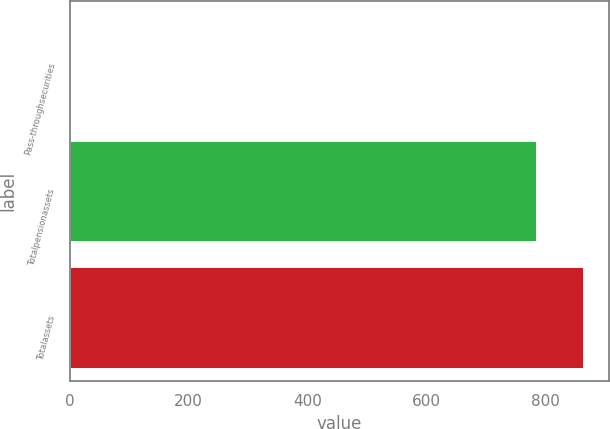Convert chart to OTSL. <chart><loc_0><loc_0><loc_500><loc_500><bar_chart><fcel>Pass-throughsecurities<fcel>Totalpensionassets<fcel>Totalassets<nl><fcel>2<fcel>785<fcel>864.4<nl></chart> 